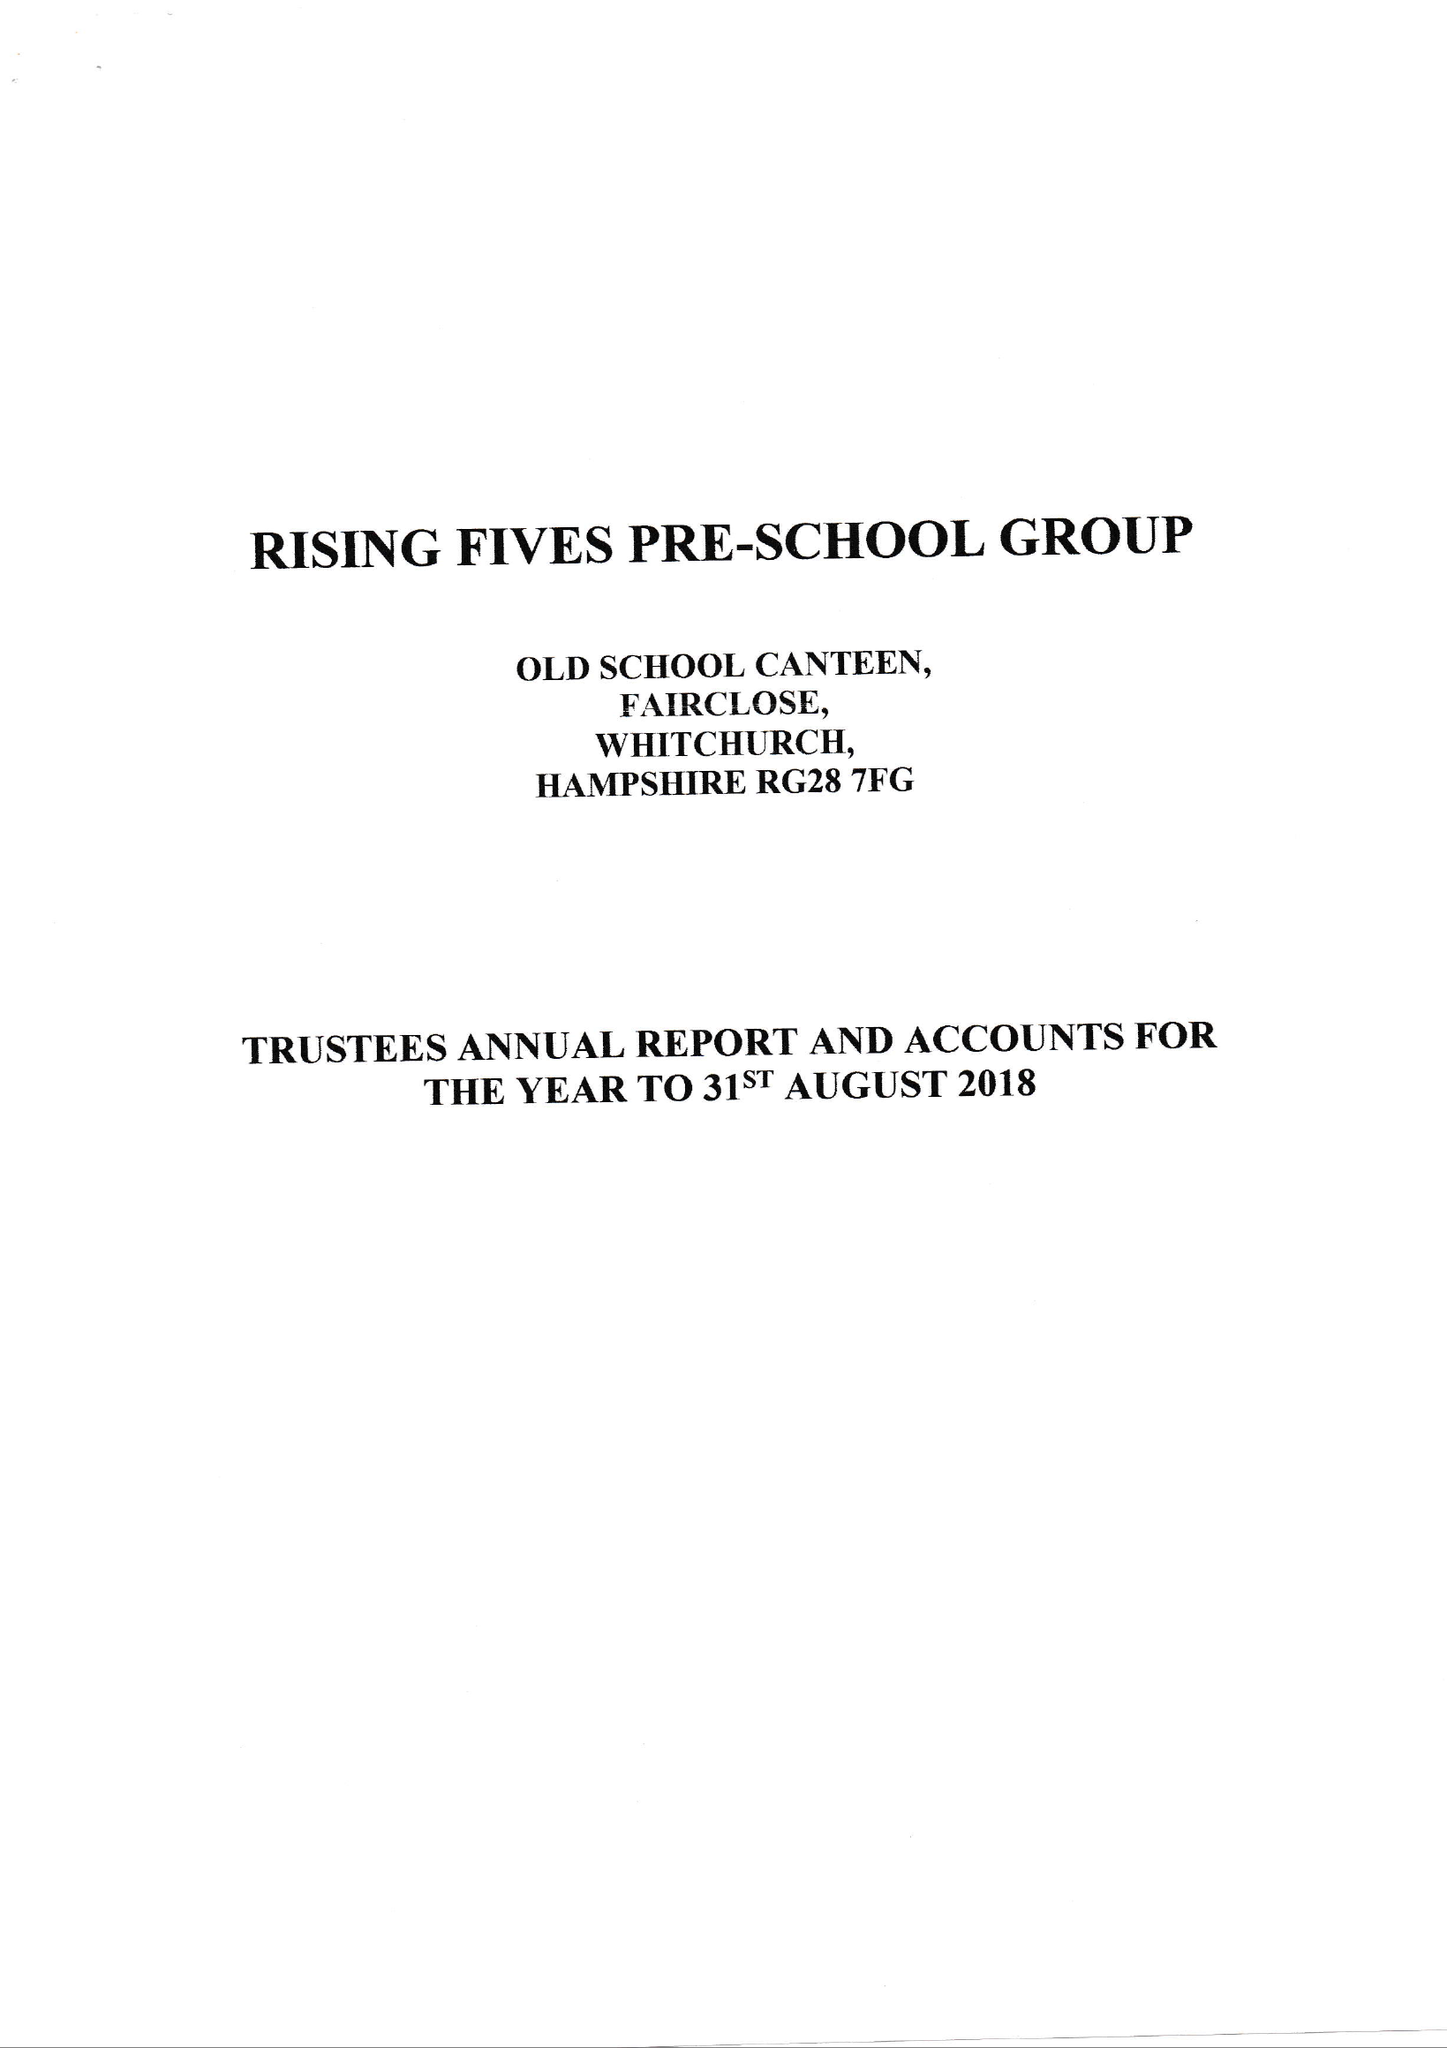What is the value for the income_annually_in_british_pounds?
Answer the question using a single word or phrase. 81756.47 